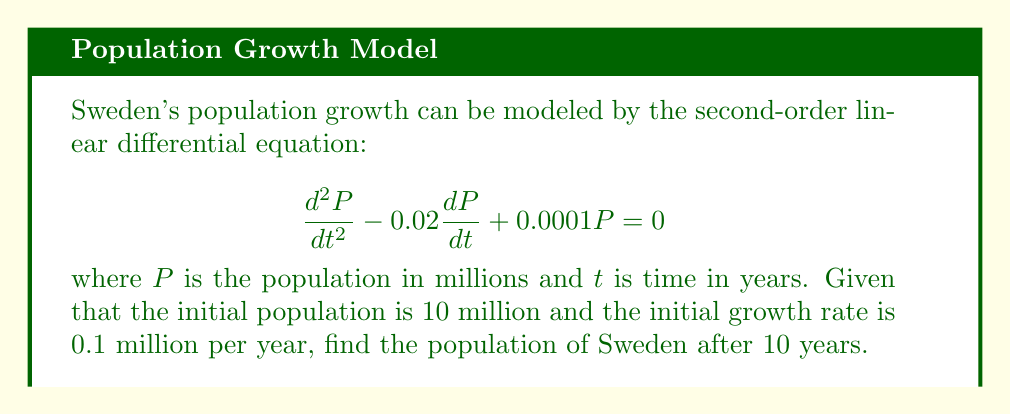Could you help me with this problem? 1) The characteristic equation for this differential equation is:
   $$r^2 - 0.02r + 0.0001 = 0$$

2) Solve using the quadratic formula:
   $$r = \frac{0.02 \pm \sqrt{0.02^2 - 4(1)(0.0001)}}{2(1)} = \frac{0.02 \pm \sqrt{0.0004 - 0.0004}}{2} = 0.01$$

3) Since we have a repeated root, the general solution is:
   $$P(t) = (C_1 + C_2t)e^{0.01t}$$

4) Use the initial conditions to find $C_1$ and $C_2$:
   $P(0) = 10$, so $C_1 = 10$
   $P'(0) = 0.1$, so $0.01C_1 + C_2 = 0.1$
   Substituting $C_1 = 10$: $0.1 + C_2 = 0.1$, therefore $C_2 = 0$

5) The particular solution is:
   $$P(t) = 10e^{0.01t}$$

6) Calculate the population after 10 years:
   $$P(10) = 10e^{0.01(10)} = 10e^{0.1} \approx 10.1052$$
Answer: 10.1052 million 